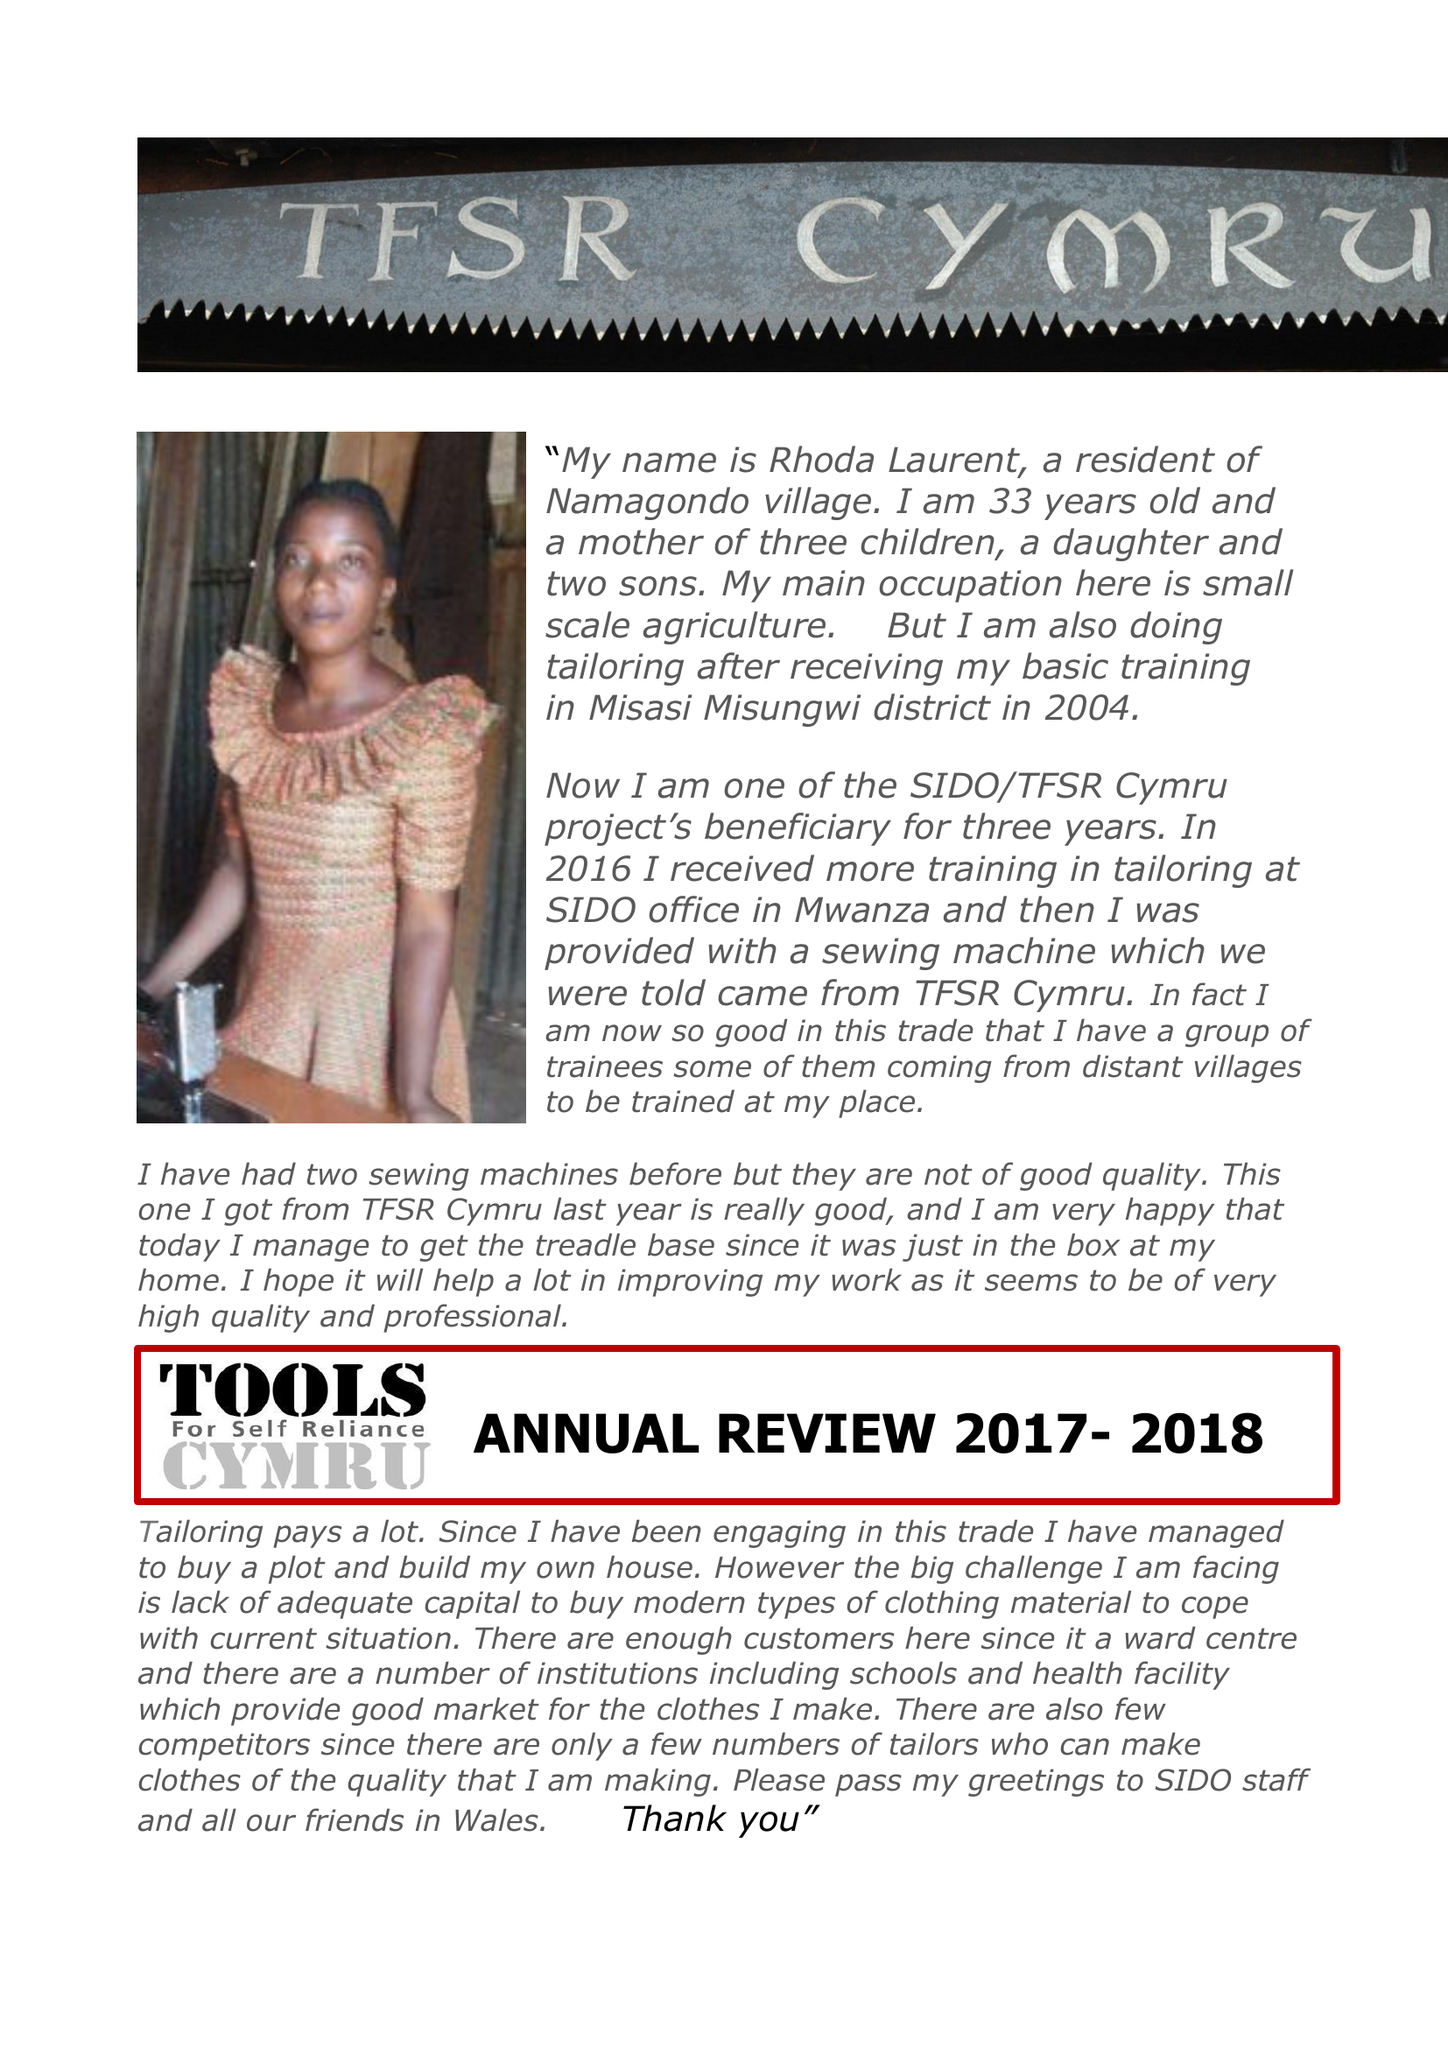What is the value for the report_date?
Answer the question using a single word or phrase. 2018-08-31 